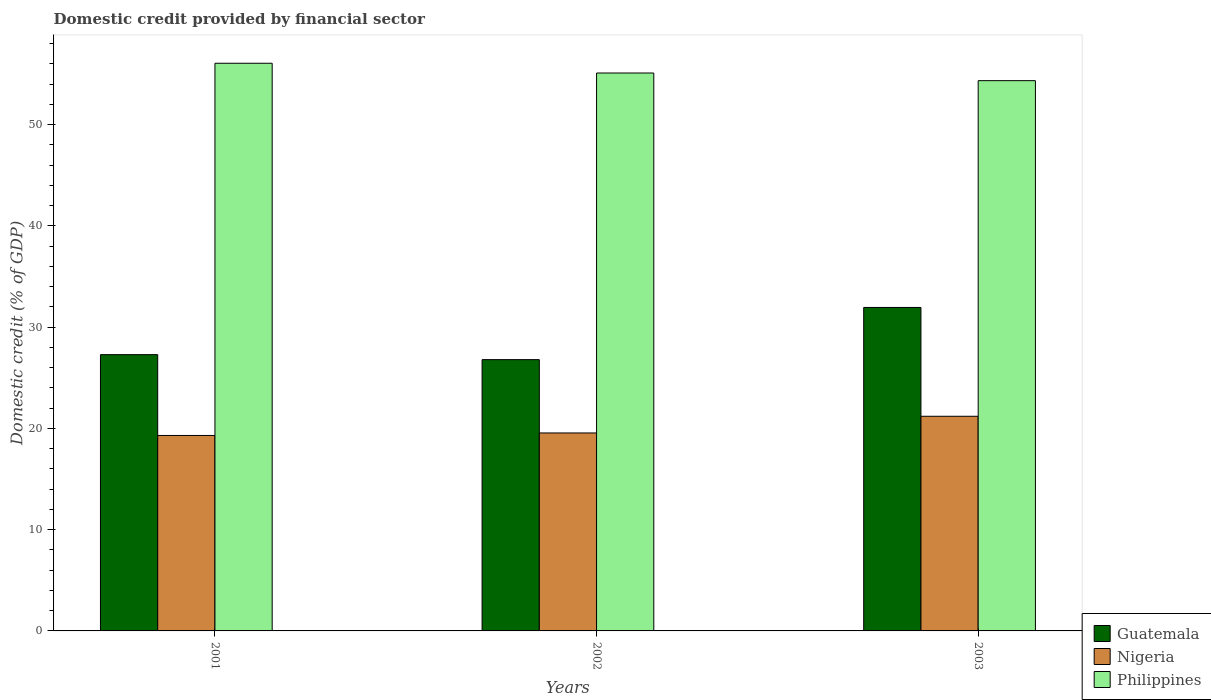How many groups of bars are there?
Make the answer very short. 3. Are the number of bars on each tick of the X-axis equal?
Offer a terse response. Yes. What is the label of the 2nd group of bars from the left?
Provide a short and direct response. 2002. In how many cases, is the number of bars for a given year not equal to the number of legend labels?
Offer a terse response. 0. What is the domestic credit in Philippines in 2002?
Make the answer very short. 55.09. Across all years, what is the maximum domestic credit in Guatemala?
Provide a succinct answer. 31.94. Across all years, what is the minimum domestic credit in Philippines?
Offer a terse response. 54.34. In which year was the domestic credit in Philippines minimum?
Offer a terse response. 2003. What is the total domestic credit in Guatemala in the graph?
Your answer should be compact. 86.01. What is the difference between the domestic credit in Philippines in 2002 and that in 2003?
Offer a very short reply. 0.76. What is the difference between the domestic credit in Philippines in 2001 and the domestic credit in Nigeria in 2002?
Your answer should be compact. 36.51. What is the average domestic credit in Nigeria per year?
Give a very brief answer. 20.02. In the year 2003, what is the difference between the domestic credit in Nigeria and domestic credit in Philippines?
Make the answer very short. -33.14. In how many years, is the domestic credit in Philippines greater than 36 %?
Your answer should be very brief. 3. What is the ratio of the domestic credit in Guatemala in 2001 to that in 2002?
Offer a very short reply. 1.02. What is the difference between the highest and the second highest domestic credit in Nigeria?
Provide a short and direct response. 1.65. What is the difference between the highest and the lowest domestic credit in Nigeria?
Provide a succinct answer. 1.9. In how many years, is the domestic credit in Nigeria greater than the average domestic credit in Nigeria taken over all years?
Your answer should be very brief. 1. Is the sum of the domestic credit in Philippines in 2001 and 2003 greater than the maximum domestic credit in Nigeria across all years?
Provide a short and direct response. Yes. What does the 1st bar from the left in 2002 represents?
Provide a succinct answer. Guatemala. What does the 1st bar from the right in 2002 represents?
Your answer should be compact. Philippines. Is it the case that in every year, the sum of the domestic credit in Nigeria and domestic credit in Guatemala is greater than the domestic credit in Philippines?
Ensure brevity in your answer.  No. Are all the bars in the graph horizontal?
Ensure brevity in your answer.  No. How many years are there in the graph?
Ensure brevity in your answer.  3. Does the graph contain any zero values?
Keep it short and to the point. No. Where does the legend appear in the graph?
Provide a short and direct response. Bottom right. How many legend labels are there?
Offer a terse response. 3. What is the title of the graph?
Your answer should be very brief. Domestic credit provided by financial sector. What is the label or title of the Y-axis?
Keep it short and to the point. Domestic credit (% of GDP). What is the Domestic credit (% of GDP) in Guatemala in 2001?
Keep it short and to the point. 27.28. What is the Domestic credit (% of GDP) in Nigeria in 2001?
Provide a succinct answer. 19.3. What is the Domestic credit (% of GDP) in Philippines in 2001?
Provide a short and direct response. 56.06. What is the Domestic credit (% of GDP) in Guatemala in 2002?
Provide a short and direct response. 26.79. What is the Domestic credit (% of GDP) in Nigeria in 2002?
Provide a succinct answer. 19.55. What is the Domestic credit (% of GDP) of Philippines in 2002?
Offer a terse response. 55.09. What is the Domestic credit (% of GDP) in Guatemala in 2003?
Ensure brevity in your answer.  31.94. What is the Domestic credit (% of GDP) in Nigeria in 2003?
Keep it short and to the point. 21.2. What is the Domestic credit (% of GDP) of Philippines in 2003?
Provide a short and direct response. 54.34. Across all years, what is the maximum Domestic credit (% of GDP) of Guatemala?
Offer a terse response. 31.94. Across all years, what is the maximum Domestic credit (% of GDP) of Nigeria?
Your answer should be compact. 21.2. Across all years, what is the maximum Domestic credit (% of GDP) of Philippines?
Make the answer very short. 56.06. Across all years, what is the minimum Domestic credit (% of GDP) in Guatemala?
Provide a succinct answer. 26.79. Across all years, what is the minimum Domestic credit (% of GDP) in Nigeria?
Keep it short and to the point. 19.3. Across all years, what is the minimum Domestic credit (% of GDP) in Philippines?
Offer a very short reply. 54.34. What is the total Domestic credit (% of GDP) of Guatemala in the graph?
Provide a short and direct response. 86.01. What is the total Domestic credit (% of GDP) of Nigeria in the graph?
Your answer should be compact. 60.05. What is the total Domestic credit (% of GDP) of Philippines in the graph?
Offer a very short reply. 165.49. What is the difference between the Domestic credit (% of GDP) in Guatemala in 2001 and that in 2002?
Ensure brevity in your answer.  0.49. What is the difference between the Domestic credit (% of GDP) of Nigeria in 2001 and that in 2002?
Ensure brevity in your answer.  -0.25. What is the difference between the Domestic credit (% of GDP) in Philippines in 2001 and that in 2002?
Provide a succinct answer. 0.96. What is the difference between the Domestic credit (% of GDP) in Guatemala in 2001 and that in 2003?
Your answer should be very brief. -4.66. What is the difference between the Domestic credit (% of GDP) of Nigeria in 2001 and that in 2003?
Make the answer very short. -1.9. What is the difference between the Domestic credit (% of GDP) in Philippines in 2001 and that in 2003?
Keep it short and to the point. 1.72. What is the difference between the Domestic credit (% of GDP) of Guatemala in 2002 and that in 2003?
Make the answer very short. -5.15. What is the difference between the Domestic credit (% of GDP) in Nigeria in 2002 and that in 2003?
Keep it short and to the point. -1.65. What is the difference between the Domestic credit (% of GDP) in Philippines in 2002 and that in 2003?
Provide a short and direct response. 0.76. What is the difference between the Domestic credit (% of GDP) of Guatemala in 2001 and the Domestic credit (% of GDP) of Nigeria in 2002?
Offer a terse response. 7.73. What is the difference between the Domestic credit (% of GDP) in Guatemala in 2001 and the Domestic credit (% of GDP) in Philippines in 2002?
Provide a succinct answer. -27.81. What is the difference between the Domestic credit (% of GDP) in Nigeria in 2001 and the Domestic credit (% of GDP) in Philippines in 2002?
Keep it short and to the point. -35.79. What is the difference between the Domestic credit (% of GDP) of Guatemala in 2001 and the Domestic credit (% of GDP) of Nigeria in 2003?
Your response must be concise. 6.08. What is the difference between the Domestic credit (% of GDP) of Guatemala in 2001 and the Domestic credit (% of GDP) of Philippines in 2003?
Your response must be concise. -27.06. What is the difference between the Domestic credit (% of GDP) in Nigeria in 2001 and the Domestic credit (% of GDP) in Philippines in 2003?
Provide a short and direct response. -35.04. What is the difference between the Domestic credit (% of GDP) of Guatemala in 2002 and the Domestic credit (% of GDP) of Nigeria in 2003?
Keep it short and to the point. 5.59. What is the difference between the Domestic credit (% of GDP) of Guatemala in 2002 and the Domestic credit (% of GDP) of Philippines in 2003?
Offer a very short reply. -27.55. What is the difference between the Domestic credit (% of GDP) in Nigeria in 2002 and the Domestic credit (% of GDP) in Philippines in 2003?
Your answer should be very brief. -34.79. What is the average Domestic credit (% of GDP) in Guatemala per year?
Offer a very short reply. 28.67. What is the average Domestic credit (% of GDP) of Nigeria per year?
Make the answer very short. 20.02. What is the average Domestic credit (% of GDP) of Philippines per year?
Your response must be concise. 55.16. In the year 2001, what is the difference between the Domestic credit (% of GDP) of Guatemala and Domestic credit (% of GDP) of Nigeria?
Keep it short and to the point. 7.98. In the year 2001, what is the difference between the Domestic credit (% of GDP) of Guatemala and Domestic credit (% of GDP) of Philippines?
Offer a very short reply. -28.77. In the year 2001, what is the difference between the Domestic credit (% of GDP) of Nigeria and Domestic credit (% of GDP) of Philippines?
Offer a terse response. -36.75. In the year 2002, what is the difference between the Domestic credit (% of GDP) in Guatemala and Domestic credit (% of GDP) in Nigeria?
Ensure brevity in your answer.  7.24. In the year 2002, what is the difference between the Domestic credit (% of GDP) of Guatemala and Domestic credit (% of GDP) of Philippines?
Provide a short and direct response. -28.3. In the year 2002, what is the difference between the Domestic credit (% of GDP) in Nigeria and Domestic credit (% of GDP) in Philippines?
Provide a short and direct response. -35.54. In the year 2003, what is the difference between the Domestic credit (% of GDP) in Guatemala and Domestic credit (% of GDP) in Nigeria?
Provide a succinct answer. 10.75. In the year 2003, what is the difference between the Domestic credit (% of GDP) in Guatemala and Domestic credit (% of GDP) in Philippines?
Offer a terse response. -22.39. In the year 2003, what is the difference between the Domestic credit (% of GDP) of Nigeria and Domestic credit (% of GDP) of Philippines?
Keep it short and to the point. -33.14. What is the ratio of the Domestic credit (% of GDP) in Guatemala in 2001 to that in 2002?
Your answer should be very brief. 1.02. What is the ratio of the Domestic credit (% of GDP) in Nigeria in 2001 to that in 2002?
Ensure brevity in your answer.  0.99. What is the ratio of the Domestic credit (% of GDP) in Philippines in 2001 to that in 2002?
Make the answer very short. 1.02. What is the ratio of the Domestic credit (% of GDP) of Guatemala in 2001 to that in 2003?
Ensure brevity in your answer.  0.85. What is the ratio of the Domestic credit (% of GDP) in Nigeria in 2001 to that in 2003?
Offer a terse response. 0.91. What is the ratio of the Domestic credit (% of GDP) of Philippines in 2001 to that in 2003?
Provide a succinct answer. 1.03. What is the ratio of the Domestic credit (% of GDP) of Guatemala in 2002 to that in 2003?
Give a very brief answer. 0.84. What is the ratio of the Domestic credit (% of GDP) in Nigeria in 2002 to that in 2003?
Offer a terse response. 0.92. What is the ratio of the Domestic credit (% of GDP) of Philippines in 2002 to that in 2003?
Offer a very short reply. 1.01. What is the difference between the highest and the second highest Domestic credit (% of GDP) of Guatemala?
Offer a very short reply. 4.66. What is the difference between the highest and the second highest Domestic credit (% of GDP) in Nigeria?
Your answer should be very brief. 1.65. What is the difference between the highest and the second highest Domestic credit (% of GDP) of Philippines?
Your answer should be compact. 0.96. What is the difference between the highest and the lowest Domestic credit (% of GDP) in Guatemala?
Offer a terse response. 5.15. What is the difference between the highest and the lowest Domestic credit (% of GDP) of Nigeria?
Keep it short and to the point. 1.9. What is the difference between the highest and the lowest Domestic credit (% of GDP) of Philippines?
Your answer should be very brief. 1.72. 